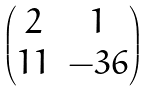Convert formula to latex. <formula><loc_0><loc_0><loc_500><loc_500>\begin{pmatrix} 2 & 1 \\ 1 1 & - 3 6 \end{pmatrix}</formula> 